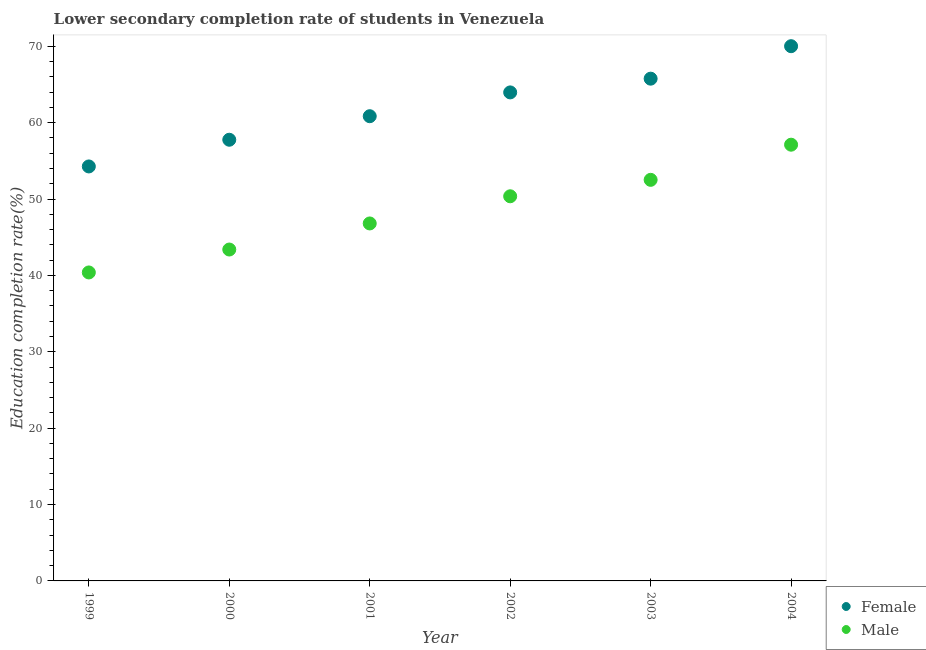How many different coloured dotlines are there?
Your answer should be compact. 2. Is the number of dotlines equal to the number of legend labels?
Offer a terse response. Yes. What is the education completion rate of female students in 2002?
Your answer should be very brief. 63.96. Across all years, what is the maximum education completion rate of male students?
Your response must be concise. 57.12. Across all years, what is the minimum education completion rate of male students?
Make the answer very short. 40.39. What is the total education completion rate of male students in the graph?
Your answer should be compact. 290.58. What is the difference between the education completion rate of female students in 2000 and that in 2004?
Offer a very short reply. -12.25. What is the difference between the education completion rate of male students in 2002 and the education completion rate of female students in 2000?
Keep it short and to the point. -7.4. What is the average education completion rate of male students per year?
Ensure brevity in your answer.  48.43. In the year 2001, what is the difference between the education completion rate of female students and education completion rate of male students?
Your answer should be compact. 14.04. What is the ratio of the education completion rate of male students in 2001 to that in 2002?
Keep it short and to the point. 0.93. Is the education completion rate of male students in 2002 less than that in 2004?
Your response must be concise. Yes. Is the difference between the education completion rate of male students in 1999 and 2001 greater than the difference between the education completion rate of female students in 1999 and 2001?
Provide a short and direct response. Yes. What is the difference between the highest and the second highest education completion rate of male students?
Ensure brevity in your answer.  4.6. What is the difference between the highest and the lowest education completion rate of female students?
Your answer should be compact. 15.75. In how many years, is the education completion rate of male students greater than the average education completion rate of male students taken over all years?
Offer a terse response. 3. Is the sum of the education completion rate of male students in 1999 and 2000 greater than the maximum education completion rate of female students across all years?
Offer a terse response. Yes. Does the education completion rate of female students monotonically increase over the years?
Offer a very short reply. Yes. Is the education completion rate of male students strictly greater than the education completion rate of female students over the years?
Offer a very short reply. No. Is the education completion rate of male students strictly less than the education completion rate of female students over the years?
Your answer should be very brief. Yes. How many dotlines are there?
Offer a terse response. 2. Are the values on the major ticks of Y-axis written in scientific E-notation?
Your response must be concise. No. Does the graph contain grids?
Your answer should be very brief. No. Where does the legend appear in the graph?
Make the answer very short. Bottom right. How are the legend labels stacked?
Offer a terse response. Vertical. What is the title of the graph?
Your answer should be very brief. Lower secondary completion rate of students in Venezuela. What is the label or title of the Y-axis?
Ensure brevity in your answer.  Education completion rate(%). What is the Education completion rate(%) of Female in 1999?
Give a very brief answer. 54.27. What is the Education completion rate(%) of Male in 1999?
Your response must be concise. 40.39. What is the Education completion rate(%) in Female in 2000?
Keep it short and to the point. 57.76. What is the Education completion rate(%) in Male in 2000?
Your answer should be compact. 43.39. What is the Education completion rate(%) in Female in 2001?
Give a very brief answer. 60.85. What is the Education completion rate(%) of Male in 2001?
Give a very brief answer. 46.81. What is the Education completion rate(%) of Female in 2002?
Your answer should be very brief. 63.96. What is the Education completion rate(%) in Male in 2002?
Your answer should be very brief. 50.36. What is the Education completion rate(%) in Female in 2003?
Keep it short and to the point. 65.76. What is the Education completion rate(%) of Male in 2003?
Provide a short and direct response. 52.51. What is the Education completion rate(%) of Female in 2004?
Give a very brief answer. 70.01. What is the Education completion rate(%) in Male in 2004?
Your response must be concise. 57.12. Across all years, what is the maximum Education completion rate(%) of Female?
Keep it short and to the point. 70.01. Across all years, what is the maximum Education completion rate(%) of Male?
Ensure brevity in your answer.  57.12. Across all years, what is the minimum Education completion rate(%) of Female?
Your answer should be very brief. 54.27. Across all years, what is the minimum Education completion rate(%) of Male?
Your response must be concise. 40.39. What is the total Education completion rate(%) of Female in the graph?
Your answer should be compact. 372.62. What is the total Education completion rate(%) of Male in the graph?
Offer a very short reply. 290.58. What is the difference between the Education completion rate(%) in Female in 1999 and that in 2000?
Your response must be concise. -3.5. What is the difference between the Education completion rate(%) in Male in 1999 and that in 2000?
Offer a terse response. -3. What is the difference between the Education completion rate(%) of Female in 1999 and that in 2001?
Ensure brevity in your answer.  -6.58. What is the difference between the Education completion rate(%) of Male in 1999 and that in 2001?
Offer a terse response. -6.42. What is the difference between the Education completion rate(%) of Female in 1999 and that in 2002?
Your response must be concise. -9.69. What is the difference between the Education completion rate(%) in Male in 1999 and that in 2002?
Provide a succinct answer. -9.97. What is the difference between the Education completion rate(%) in Female in 1999 and that in 2003?
Provide a succinct answer. -11.49. What is the difference between the Education completion rate(%) in Male in 1999 and that in 2003?
Keep it short and to the point. -12.13. What is the difference between the Education completion rate(%) of Female in 1999 and that in 2004?
Keep it short and to the point. -15.75. What is the difference between the Education completion rate(%) in Male in 1999 and that in 2004?
Provide a short and direct response. -16.73. What is the difference between the Education completion rate(%) of Female in 2000 and that in 2001?
Offer a very short reply. -3.08. What is the difference between the Education completion rate(%) in Male in 2000 and that in 2001?
Make the answer very short. -3.41. What is the difference between the Education completion rate(%) in Female in 2000 and that in 2002?
Give a very brief answer. -6.2. What is the difference between the Education completion rate(%) in Male in 2000 and that in 2002?
Make the answer very short. -6.97. What is the difference between the Education completion rate(%) of Female in 2000 and that in 2003?
Offer a terse response. -8. What is the difference between the Education completion rate(%) in Male in 2000 and that in 2003?
Offer a terse response. -9.12. What is the difference between the Education completion rate(%) in Female in 2000 and that in 2004?
Ensure brevity in your answer.  -12.25. What is the difference between the Education completion rate(%) in Male in 2000 and that in 2004?
Provide a short and direct response. -13.73. What is the difference between the Education completion rate(%) of Female in 2001 and that in 2002?
Offer a terse response. -3.12. What is the difference between the Education completion rate(%) in Male in 2001 and that in 2002?
Provide a short and direct response. -3.56. What is the difference between the Education completion rate(%) of Female in 2001 and that in 2003?
Your answer should be compact. -4.91. What is the difference between the Education completion rate(%) in Male in 2001 and that in 2003?
Provide a succinct answer. -5.71. What is the difference between the Education completion rate(%) in Female in 2001 and that in 2004?
Offer a very short reply. -9.17. What is the difference between the Education completion rate(%) in Male in 2001 and that in 2004?
Give a very brief answer. -10.31. What is the difference between the Education completion rate(%) of Female in 2002 and that in 2003?
Offer a terse response. -1.8. What is the difference between the Education completion rate(%) of Male in 2002 and that in 2003?
Your response must be concise. -2.15. What is the difference between the Education completion rate(%) in Female in 2002 and that in 2004?
Ensure brevity in your answer.  -6.05. What is the difference between the Education completion rate(%) of Male in 2002 and that in 2004?
Provide a short and direct response. -6.76. What is the difference between the Education completion rate(%) of Female in 2003 and that in 2004?
Ensure brevity in your answer.  -4.25. What is the difference between the Education completion rate(%) in Male in 2003 and that in 2004?
Keep it short and to the point. -4.6. What is the difference between the Education completion rate(%) in Female in 1999 and the Education completion rate(%) in Male in 2000?
Your answer should be compact. 10.88. What is the difference between the Education completion rate(%) in Female in 1999 and the Education completion rate(%) in Male in 2001?
Keep it short and to the point. 7.46. What is the difference between the Education completion rate(%) of Female in 1999 and the Education completion rate(%) of Male in 2002?
Provide a succinct answer. 3.91. What is the difference between the Education completion rate(%) of Female in 1999 and the Education completion rate(%) of Male in 2003?
Ensure brevity in your answer.  1.75. What is the difference between the Education completion rate(%) in Female in 1999 and the Education completion rate(%) in Male in 2004?
Your response must be concise. -2.85. What is the difference between the Education completion rate(%) of Female in 2000 and the Education completion rate(%) of Male in 2001?
Your answer should be compact. 10.96. What is the difference between the Education completion rate(%) in Female in 2000 and the Education completion rate(%) in Male in 2002?
Provide a succinct answer. 7.4. What is the difference between the Education completion rate(%) of Female in 2000 and the Education completion rate(%) of Male in 2003?
Keep it short and to the point. 5.25. What is the difference between the Education completion rate(%) in Female in 2000 and the Education completion rate(%) in Male in 2004?
Make the answer very short. 0.65. What is the difference between the Education completion rate(%) in Female in 2001 and the Education completion rate(%) in Male in 2002?
Give a very brief answer. 10.48. What is the difference between the Education completion rate(%) of Female in 2001 and the Education completion rate(%) of Male in 2003?
Give a very brief answer. 8.33. What is the difference between the Education completion rate(%) of Female in 2001 and the Education completion rate(%) of Male in 2004?
Your answer should be compact. 3.73. What is the difference between the Education completion rate(%) of Female in 2002 and the Education completion rate(%) of Male in 2003?
Keep it short and to the point. 11.45. What is the difference between the Education completion rate(%) of Female in 2002 and the Education completion rate(%) of Male in 2004?
Ensure brevity in your answer.  6.85. What is the difference between the Education completion rate(%) in Female in 2003 and the Education completion rate(%) in Male in 2004?
Provide a short and direct response. 8.64. What is the average Education completion rate(%) of Female per year?
Make the answer very short. 62.1. What is the average Education completion rate(%) in Male per year?
Give a very brief answer. 48.43. In the year 1999, what is the difference between the Education completion rate(%) in Female and Education completion rate(%) in Male?
Make the answer very short. 13.88. In the year 2000, what is the difference between the Education completion rate(%) of Female and Education completion rate(%) of Male?
Offer a terse response. 14.37. In the year 2001, what is the difference between the Education completion rate(%) in Female and Education completion rate(%) in Male?
Your answer should be compact. 14.04. In the year 2002, what is the difference between the Education completion rate(%) of Female and Education completion rate(%) of Male?
Your answer should be very brief. 13.6. In the year 2003, what is the difference between the Education completion rate(%) of Female and Education completion rate(%) of Male?
Ensure brevity in your answer.  13.25. In the year 2004, what is the difference between the Education completion rate(%) in Female and Education completion rate(%) in Male?
Give a very brief answer. 12.9. What is the ratio of the Education completion rate(%) of Female in 1999 to that in 2000?
Offer a very short reply. 0.94. What is the ratio of the Education completion rate(%) of Male in 1999 to that in 2000?
Offer a terse response. 0.93. What is the ratio of the Education completion rate(%) of Female in 1999 to that in 2001?
Keep it short and to the point. 0.89. What is the ratio of the Education completion rate(%) in Male in 1999 to that in 2001?
Your answer should be very brief. 0.86. What is the ratio of the Education completion rate(%) of Female in 1999 to that in 2002?
Your answer should be very brief. 0.85. What is the ratio of the Education completion rate(%) in Male in 1999 to that in 2002?
Offer a terse response. 0.8. What is the ratio of the Education completion rate(%) of Female in 1999 to that in 2003?
Your answer should be very brief. 0.83. What is the ratio of the Education completion rate(%) of Male in 1999 to that in 2003?
Give a very brief answer. 0.77. What is the ratio of the Education completion rate(%) of Female in 1999 to that in 2004?
Provide a succinct answer. 0.78. What is the ratio of the Education completion rate(%) of Male in 1999 to that in 2004?
Offer a terse response. 0.71. What is the ratio of the Education completion rate(%) in Female in 2000 to that in 2001?
Ensure brevity in your answer.  0.95. What is the ratio of the Education completion rate(%) in Male in 2000 to that in 2001?
Offer a terse response. 0.93. What is the ratio of the Education completion rate(%) of Female in 2000 to that in 2002?
Offer a very short reply. 0.9. What is the ratio of the Education completion rate(%) of Male in 2000 to that in 2002?
Offer a very short reply. 0.86. What is the ratio of the Education completion rate(%) in Female in 2000 to that in 2003?
Offer a very short reply. 0.88. What is the ratio of the Education completion rate(%) of Male in 2000 to that in 2003?
Give a very brief answer. 0.83. What is the ratio of the Education completion rate(%) of Female in 2000 to that in 2004?
Give a very brief answer. 0.82. What is the ratio of the Education completion rate(%) of Male in 2000 to that in 2004?
Your answer should be very brief. 0.76. What is the ratio of the Education completion rate(%) in Female in 2001 to that in 2002?
Provide a succinct answer. 0.95. What is the ratio of the Education completion rate(%) in Male in 2001 to that in 2002?
Your answer should be compact. 0.93. What is the ratio of the Education completion rate(%) of Female in 2001 to that in 2003?
Make the answer very short. 0.93. What is the ratio of the Education completion rate(%) in Male in 2001 to that in 2003?
Give a very brief answer. 0.89. What is the ratio of the Education completion rate(%) of Female in 2001 to that in 2004?
Offer a terse response. 0.87. What is the ratio of the Education completion rate(%) in Male in 2001 to that in 2004?
Your answer should be compact. 0.82. What is the ratio of the Education completion rate(%) in Female in 2002 to that in 2003?
Give a very brief answer. 0.97. What is the ratio of the Education completion rate(%) of Female in 2002 to that in 2004?
Offer a very short reply. 0.91. What is the ratio of the Education completion rate(%) of Male in 2002 to that in 2004?
Your answer should be compact. 0.88. What is the ratio of the Education completion rate(%) of Female in 2003 to that in 2004?
Make the answer very short. 0.94. What is the ratio of the Education completion rate(%) of Male in 2003 to that in 2004?
Ensure brevity in your answer.  0.92. What is the difference between the highest and the second highest Education completion rate(%) of Female?
Provide a succinct answer. 4.25. What is the difference between the highest and the second highest Education completion rate(%) in Male?
Your answer should be very brief. 4.6. What is the difference between the highest and the lowest Education completion rate(%) of Female?
Your answer should be very brief. 15.75. What is the difference between the highest and the lowest Education completion rate(%) in Male?
Give a very brief answer. 16.73. 